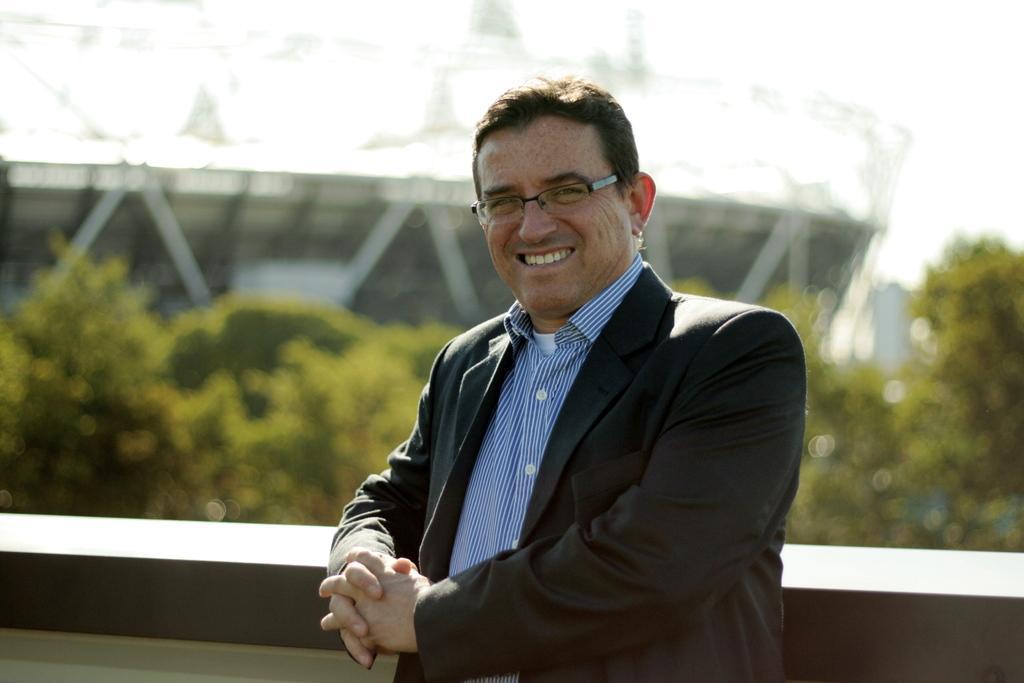Could you give a brief overview of what you see in this image? In the middle of the image a man is standing and smiling. Behind him there is wall and trees and building. At the top of the image there is sky. 